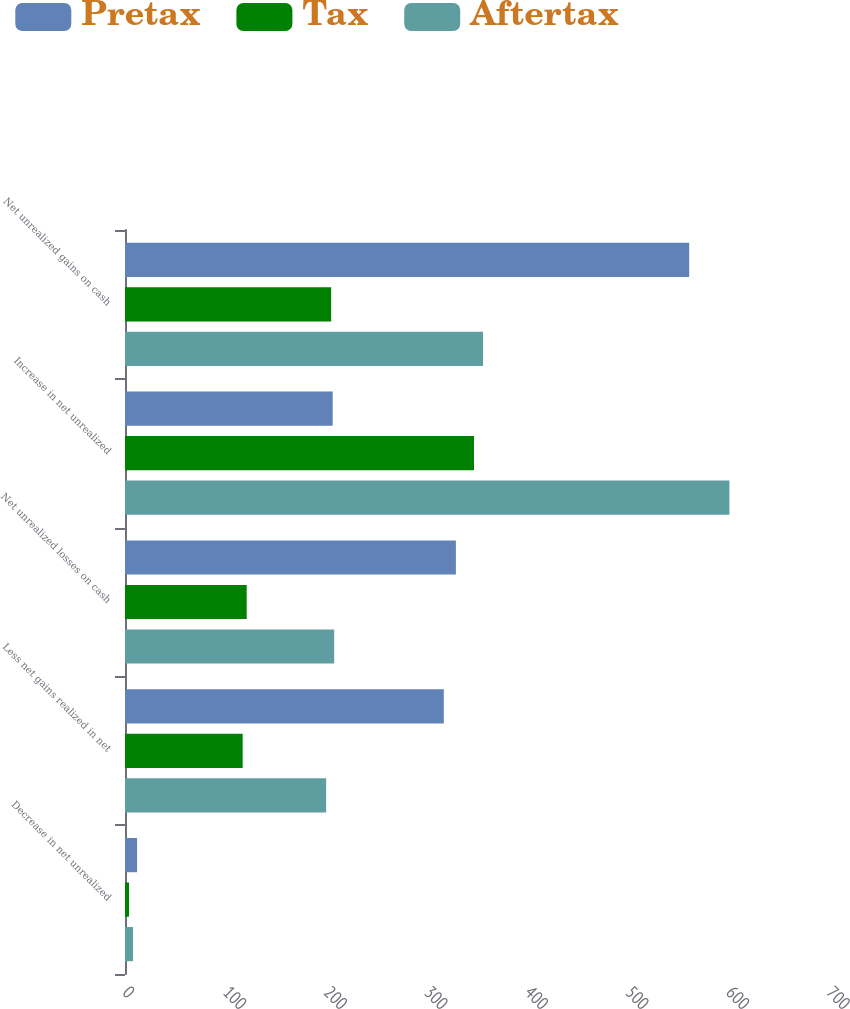Convert chart. <chart><loc_0><loc_0><loc_500><loc_500><stacked_bar_chart><ecel><fcel>Decrease in net unrealized<fcel>Less net gains realized in net<fcel>Net unrealized losses on cash<fcel>Increase in net unrealized<fcel>Net unrealized gains on cash<nl><fcel>Pretax<fcel>12<fcel>317<fcel>329<fcel>206.5<fcel>561<nl><fcel>Tax<fcel>4<fcel>117<fcel>121<fcel>347<fcel>205<nl><fcel>Aftertax<fcel>8<fcel>200<fcel>208<fcel>601<fcel>356<nl></chart> 